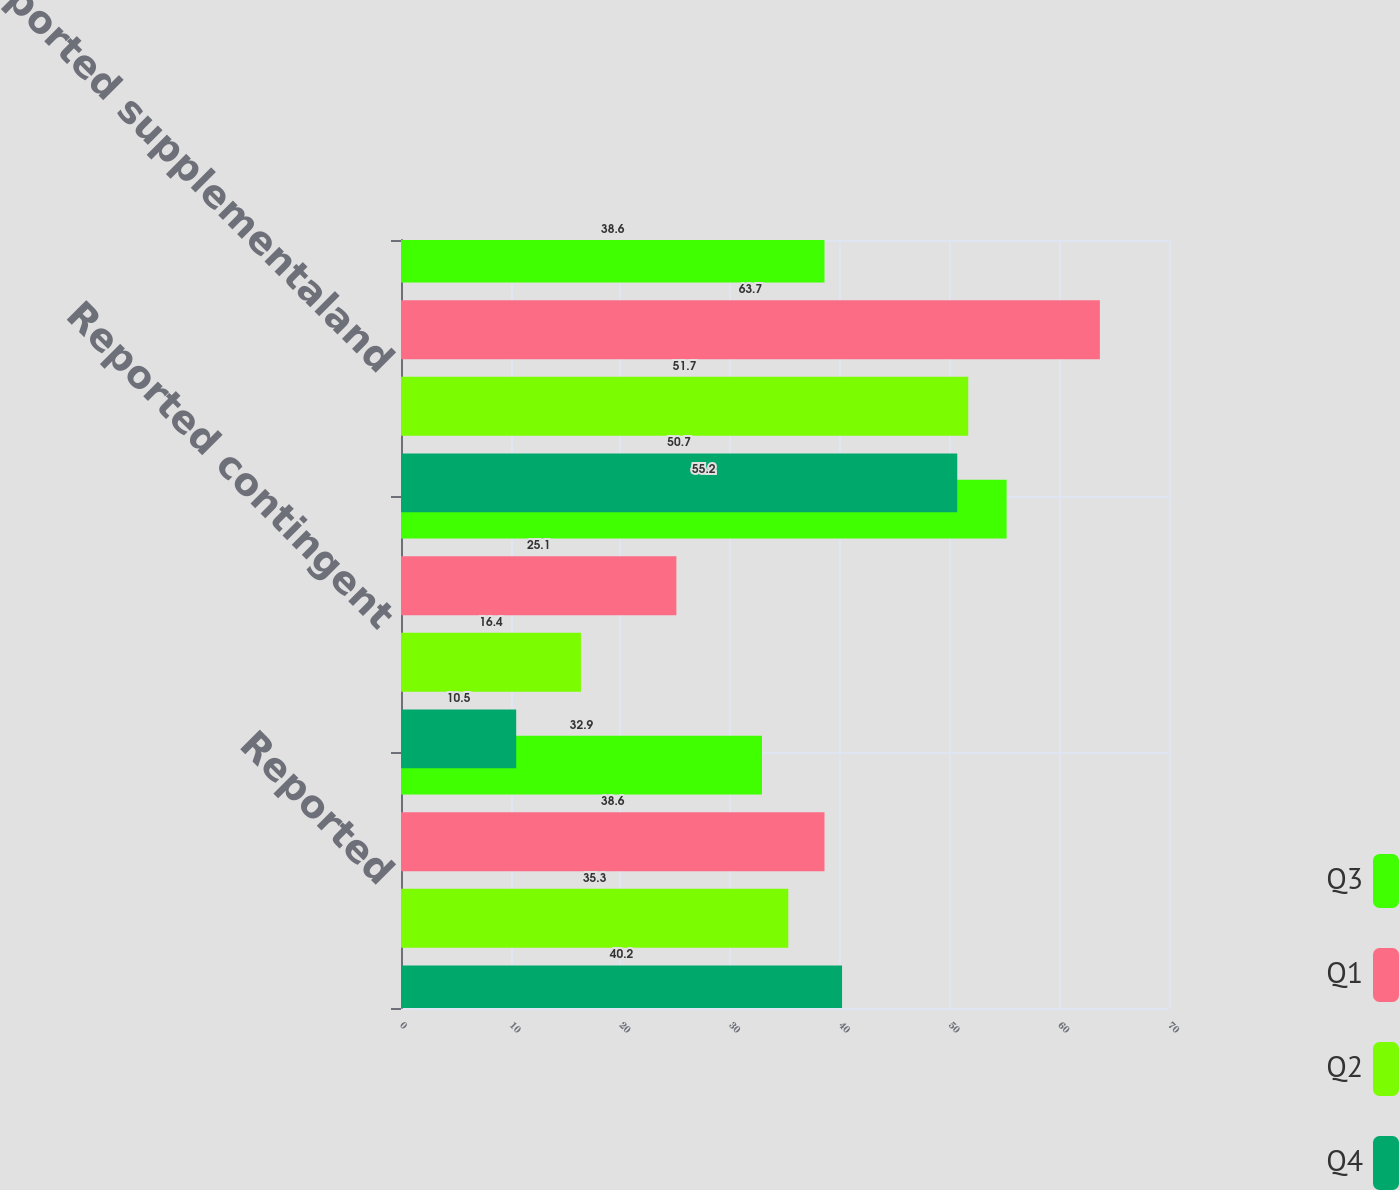Convert chart to OTSL. <chart><loc_0><loc_0><loc_500><loc_500><stacked_bar_chart><ecel><fcel>Reported<fcel>Reported contingent<fcel>Reported supplementaland<nl><fcel>Q3<fcel>32.9<fcel>55.2<fcel>38.6<nl><fcel>Q1<fcel>38.6<fcel>25.1<fcel>63.7<nl><fcel>Q2<fcel>35.3<fcel>16.4<fcel>51.7<nl><fcel>Q4<fcel>40.2<fcel>10.5<fcel>50.7<nl></chart> 